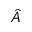Convert formula to latex. <formula><loc_0><loc_0><loc_500><loc_500>\hat { A }</formula> 